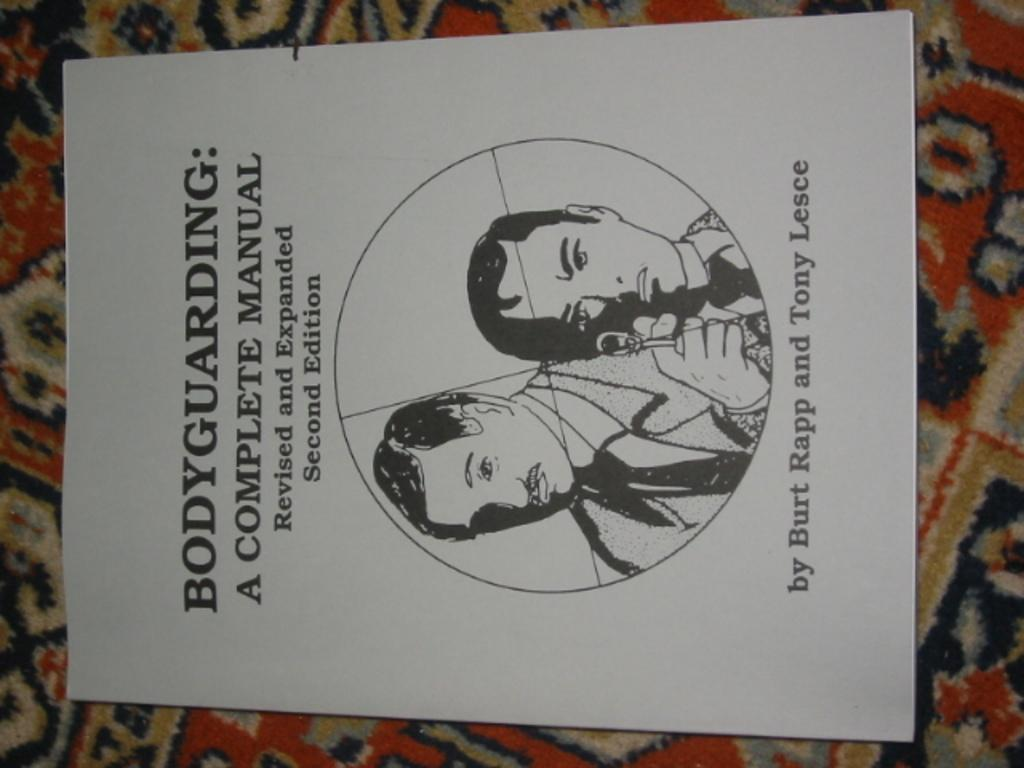<image>
Provide a brief description of the given image. A white manual about bodyguarding sits on a colorful fabric. 